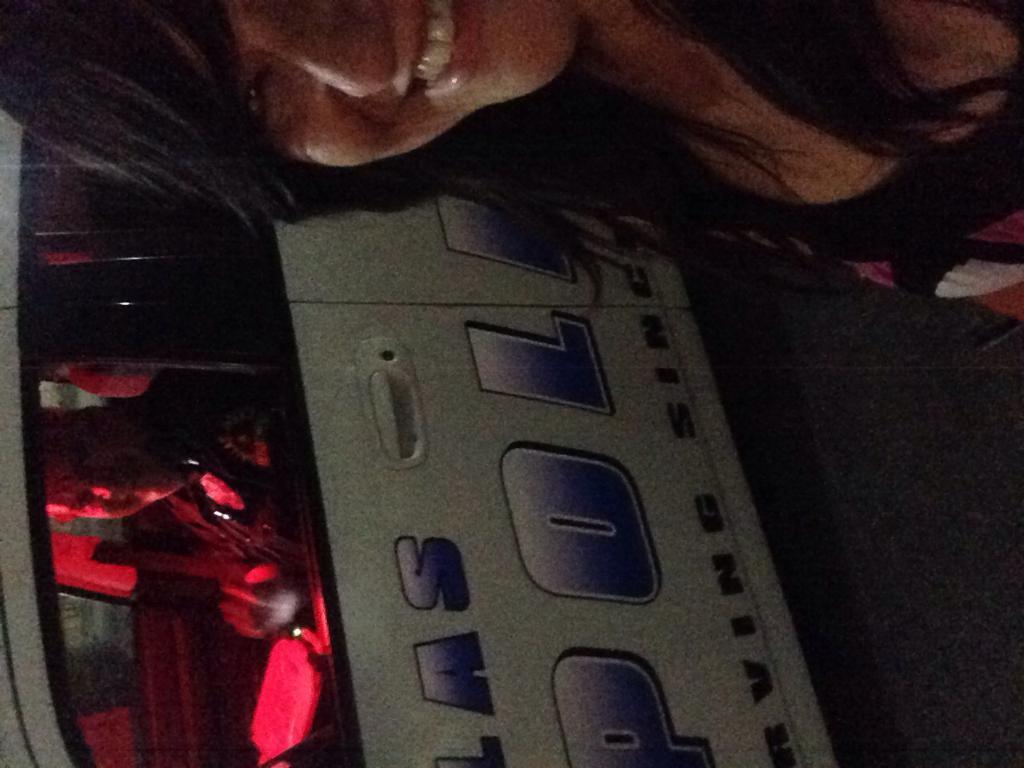Who is present in the image? There is a woman in the image. What is the woman doing in the image? The woman is smiling. What else can be seen in the image besides the woman? There is a vehicle in the image. Who is inside the vehicle? There is a person in the vehicle. How is the person in the vehicle feeling? The person in the vehicle is smiling. What type of cup is the person in the vehicle holding? There is no cup present in the image. How many tickets can be seen in the image? There are no tickets visible in the image. 